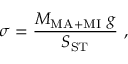<formula> <loc_0><loc_0><loc_500><loc_500>\sigma = \frac { M _ { M A + M I } g } { S _ { S T } } ,</formula> 